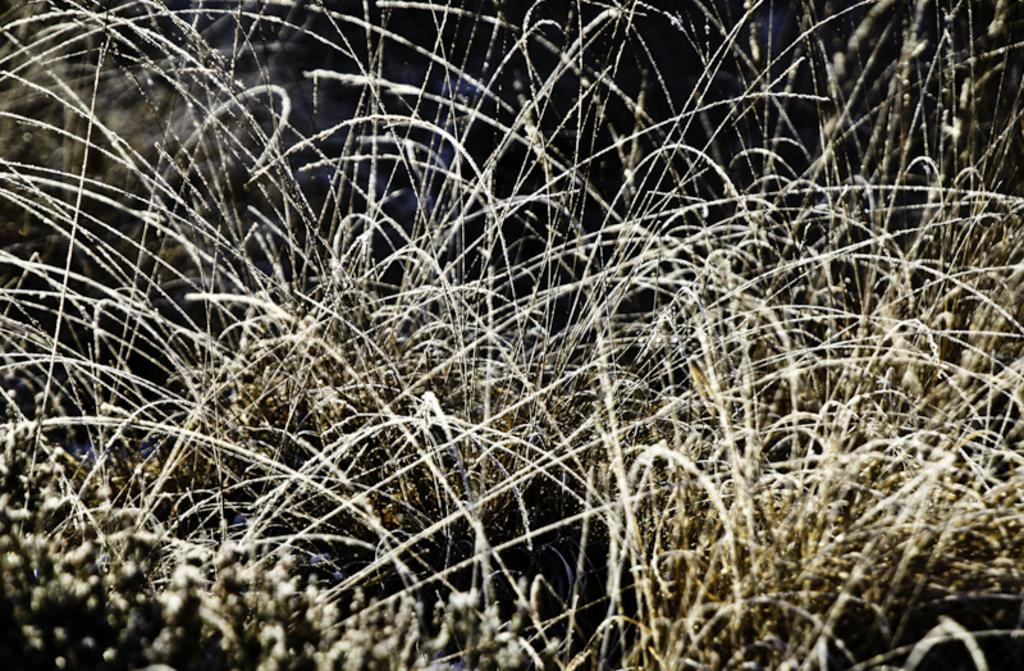What type of vegetation is visible in the image? There is grass in the image. Can you describe the condition of the grass? There might be snow on the grass. What type of sugar can be seen on the books in the image? There are no books or sugar present in the image; it only features grass and possibly snow. 